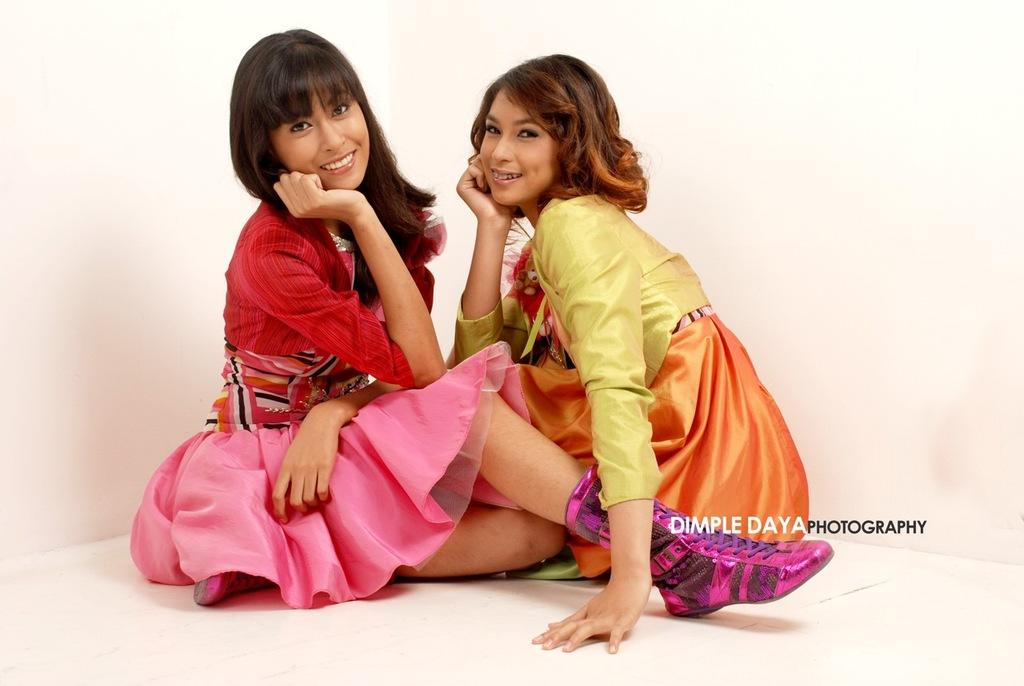How many people are in the image? There are two women in the image. What are the women doing in the image? The women are sitting. What expression do the women have in the image? The women are smiling. What can be seen in the background of the image? There is a wall visible in the background of the image. How many beds are visible in the image? There are no beds visible in the image. What type of division can be seen between the women in the image? There is no visible division between the women in the image. 